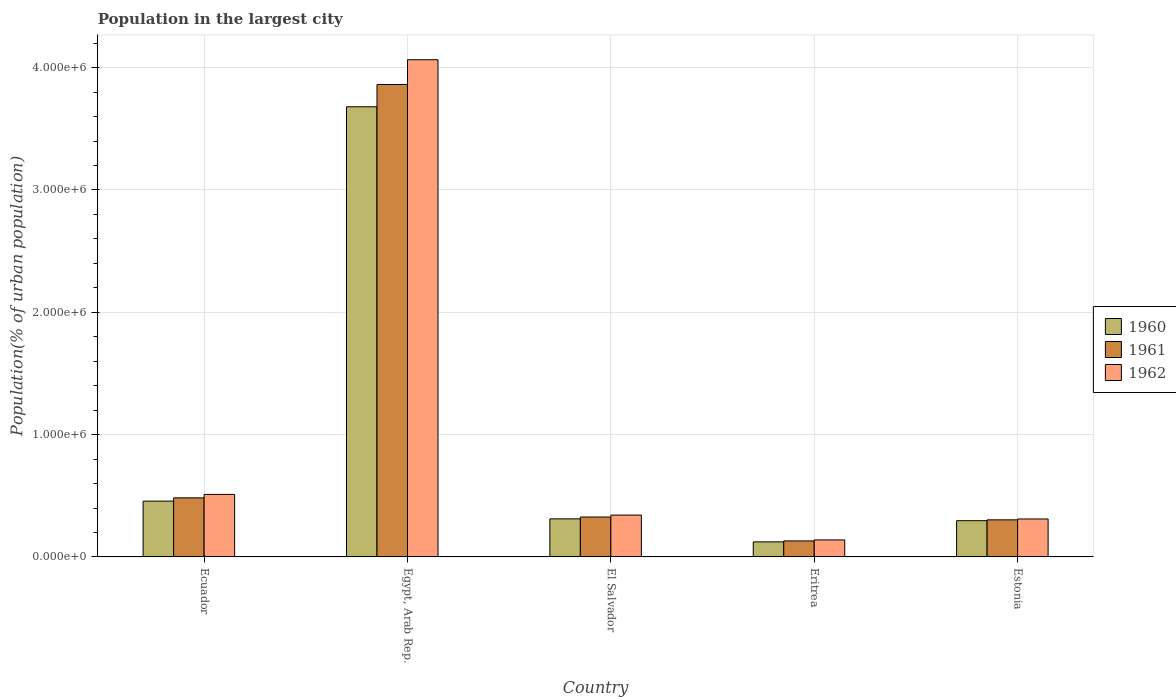Are the number of bars per tick equal to the number of legend labels?
Provide a succinct answer. Yes. Are the number of bars on each tick of the X-axis equal?
Provide a short and direct response. Yes. How many bars are there on the 1st tick from the right?
Ensure brevity in your answer.  3. What is the label of the 3rd group of bars from the left?
Make the answer very short. El Salvador. In how many cases, is the number of bars for a given country not equal to the number of legend labels?
Offer a very short reply. 0. What is the population in the largest city in 1960 in El Salvador?
Provide a succinct answer. 3.11e+05. Across all countries, what is the maximum population in the largest city in 1961?
Your answer should be very brief. 3.86e+06. Across all countries, what is the minimum population in the largest city in 1961?
Ensure brevity in your answer.  1.31e+05. In which country was the population in the largest city in 1960 maximum?
Keep it short and to the point. Egypt, Arab Rep. In which country was the population in the largest city in 1960 minimum?
Ensure brevity in your answer.  Eritrea. What is the total population in the largest city in 1960 in the graph?
Ensure brevity in your answer.  4.87e+06. What is the difference between the population in the largest city in 1962 in El Salvador and that in Estonia?
Offer a terse response. 3.18e+04. What is the difference between the population in the largest city in 1960 in Estonia and the population in the largest city in 1961 in Ecuador?
Make the answer very short. -1.87e+05. What is the average population in the largest city in 1960 per country?
Your answer should be compact. 9.73e+05. What is the difference between the population in the largest city of/in 1960 and population in the largest city of/in 1961 in Estonia?
Provide a succinct answer. -6898. In how many countries, is the population in the largest city in 1960 greater than 2200000 %?
Your answer should be very brief. 1. What is the ratio of the population in the largest city in 1961 in Ecuador to that in Eritrea?
Ensure brevity in your answer.  3.69. Is the population in the largest city in 1962 in Egypt, Arab Rep. less than that in El Salvador?
Give a very brief answer. No. What is the difference between the highest and the second highest population in the largest city in 1960?
Provide a succinct answer. 3.22e+06. What is the difference between the highest and the lowest population in the largest city in 1961?
Keep it short and to the point. 3.73e+06. In how many countries, is the population in the largest city in 1962 greater than the average population in the largest city in 1962 taken over all countries?
Your response must be concise. 1. What does the 3rd bar from the left in Egypt, Arab Rep. represents?
Your response must be concise. 1962. Is it the case that in every country, the sum of the population in the largest city in 1962 and population in the largest city in 1960 is greater than the population in the largest city in 1961?
Provide a short and direct response. Yes. How many bars are there?
Offer a very short reply. 15. Does the graph contain any zero values?
Your answer should be compact. No. Where does the legend appear in the graph?
Keep it short and to the point. Center right. How are the legend labels stacked?
Your answer should be very brief. Vertical. What is the title of the graph?
Provide a short and direct response. Population in the largest city. Does "2009" appear as one of the legend labels in the graph?
Ensure brevity in your answer.  No. What is the label or title of the X-axis?
Your answer should be very brief. Country. What is the label or title of the Y-axis?
Your answer should be compact. Population(% of urban population). What is the Population(% of urban population) of 1960 in Ecuador?
Provide a succinct answer. 4.56e+05. What is the Population(% of urban population) in 1961 in Ecuador?
Ensure brevity in your answer.  4.83e+05. What is the Population(% of urban population) in 1962 in Ecuador?
Your answer should be compact. 5.11e+05. What is the Population(% of urban population) of 1960 in Egypt, Arab Rep.?
Keep it short and to the point. 3.68e+06. What is the Population(% of urban population) of 1961 in Egypt, Arab Rep.?
Make the answer very short. 3.86e+06. What is the Population(% of urban population) of 1962 in Egypt, Arab Rep.?
Provide a succinct answer. 4.06e+06. What is the Population(% of urban population) of 1960 in El Salvador?
Provide a short and direct response. 3.11e+05. What is the Population(% of urban population) in 1961 in El Salvador?
Your response must be concise. 3.26e+05. What is the Population(% of urban population) of 1962 in El Salvador?
Provide a succinct answer. 3.42e+05. What is the Population(% of urban population) in 1960 in Eritrea?
Make the answer very short. 1.23e+05. What is the Population(% of urban population) of 1961 in Eritrea?
Keep it short and to the point. 1.31e+05. What is the Population(% of urban population) in 1962 in Eritrea?
Offer a very short reply. 1.39e+05. What is the Population(% of urban population) of 1960 in Estonia?
Offer a terse response. 2.96e+05. What is the Population(% of urban population) in 1961 in Estonia?
Provide a short and direct response. 3.03e+05. What is the Population(% of urban population) of 1962 in Estonia?
Make the answer very short. 3.10e+05. Across all countries, what is the maximum Population(% of urban population) in 1960?
Offer a terse response. 3.68e+06. Across all countries, what is the maximum Population(% of urban population) in 1961?
Give a very brief answer. 3.86e+06. Across all countries, what is the maximum Population(% of urban population) in 1962?
Keep it short and to the point. 4.06e+06. Across all countries, what is the minimum Population(% of urban population) in 1960?
Your answer should be compact. 1.23e+05. Across all countries, what is the minimum Population(% of urban population) of 1961?
Offer a very short reply. 1.31e+05. Across all countries, what is the minimum Population(% of urban population) of 1962?
Your answer should be very brief. 1.39e+05. What is the total Population(% of urban population) of 1960 in the graph?
Your response must be concise. 4.87e+06. What is the total Population(% of urban population) of 1961 in the graph?
Give a very brief answer. 5.11e+06. What is the total Population(% of urban population) of 1962 in the graph?
Your answer should be very brief. 5.37e+06. What is the difference between the Population(% of urban population) in 1960 in Ecuador and that in Egypt, Arab Rep.?
Your answer should be very brief. -3.22e+06. What is the difference between the Population(% of urban population) in 1961 in Ecuador and that in Egypt, Arab Rep.?
Provide a short and direct response. -3.38e+06. What is the difference between the Population(% of urban population) of 1962 in Ecuador and that in Egypt, Arab Rep.?
Ensure brevity in your answer.  -3.55e+06. What is the difference between the Population(% of urban population) in 1960 in Ecuador and that in El Salvador?
Offer a terse response. 1.45e+05. What is the difference between the Population(% of urban population) in 1961 in Ecuador and that in El Salvador?
Provide a short and direct response. 1.57e+05. What is the difference between the Population(% of urban population) of 1962 in Ecuador and that in El Salvador?
Keep it short and to the point. 1.69e+05. What is the difference between the Population(% of urban population) of 1960 in Ecuador and that in Eritrea?
Ensure brevity in your answer.  3.33e+05. What is the difference between the Population(% of urban population) in 1961 in Ecuador and that in Eritrea?
Ensure brevity in your answer.  3.52e+05. What is the difference between the Population(% of urban population) in 1962 in Ecuador and that in Eritrea?
Offer a terse response. 3.72e+05. What is the difference between the Population(% of urban population) of 1960 in Ecuador and that in Estonia?
Offer a terse response. 1.60e+05. What is the difference between the Population(% of urban population) in 1961 in Ecuador and that in Estonia?
Offer a terse response. 1.80e+05. What is the difference between the Population(% of urban population) of 1962 in Ecuador and that in Estonia?
Offer a very short reply. 2.01e+05. What is the difference between the Population(% of urban population) in 1960 in Egypt, Arab Rep. and that in El Salvador?
Ensure brevity in your answer.  3.37e+06. What is the difference between the Population(% of urban population) in 1961 in Egypt, Arab Rep. and that in El Salvador?
Provide a short and direct response. 3.54e+06. What is the difference between the Population(% of urban population) of 1962 in Egypt, Arab Rep. and that in El Salvador?
Give a very brief answer. 3.72e+06. What is the difference between the Population(% of urban population) in 1960 in Egypt, Arab Rep. and that in Eritrea?
Make the answer very short. 3.56e+06. What is the difference between the Population(% of urban population) of 1961 in Egypt, Arab Rep. and that in Eritrea?
Provide a short and direct response. 3.73e+06. What is the difference between the Population(% of urban population) in 1962 in Egypt, Arab Rep. and that in Eritrea?
Ensure brevity in your answer.  3.93e+06. What is the difference between the Population(% of urban population) in 1960 in Egypt, Arab Rep. and that in Estonia?
Your response must be concise. 3.38e+06. What is the difference between the Population(% of urban population) of 1961 in Egypt, Arab Rep. and that in Estonia?
Offer a terse response. 3.56e+06. What is the difference between the Population(% of urban population) of 1962 in Egypt, Arab Rep. and that in Estonia?
Offer a very short reply. 3.75e+06. What is the difference between the Population(% of urban population) of 1960 in El Salvador and that in Eritrea?
Offer a terse response. 1.88e+05. What is the difference between the Population(% of urban population) in 1961 in El Salvador and that in Eritrea?
Keep it short and to the point. 1.95e+05. What is the difference between the Population(% of urban population) of 1962 in El Salvador and that in Eritrea?
Provide a succinct answer. 2.03e+05. What is the difference between the Population(% of urban population) of 1960 in El Salvador and that in Estonia?
Make the answer very short. 1.49e+04. What is the difference between the Population(% of urban population) in 1961 in El Salvador and that in Estonia?
Offer a very short reply. 2.30e+04. What is the difference between the Population(% of urban population) in 1962 in El Salvador and that in Estonia?
Offer a terse response. 3.18e+04. What is the difference between the Population(% of urban population) in 1960 in Eritrea and that in Estonia?
Ensure brevity in your answer.  -1.73e+05. What is the difference between the Population(% of urban population) in 1961 in Eritrea and that in Estonia?
Your answer should be very brief. -1.72e+05. What is the difference between the Population(% of urban population) in 1962 in Eritrea and that in Estonia?
Give a very brief answer. -1.71e+05. What is the difference between the Population(% of urban population) in 1960 in Ecuador and the Population(% of urban population) in 1961 in Egypt, Arab Rep.?
Give a very brief answer. -3.41e+06. What is the difference between the Population(% of urban population) in 1960 in Ecuador and the Population(% of urban population) in 1962 in Egypt, Arab Rep.?
Your answer should be compact. -3.61e+06. What is the difference between the Population(% of urban population) in 1961 in Ecuador and the Population(% of urban population) in 1962 in Egypt, Arab Rep.?
Your response must be concise. -3.58e+06. What is the difference between the Population(% of urban population) in 1960 in Ecuador and the Population(% of urban population) in 1961 in El Salvador?
Offer a very short reply. 1.30e+05. What is the difference between the Population(% of urban population) in 1960 in Ecuador and the Population(% of urban population) in 1962 in El Salvador?
Your answer should be compact. 1.14e+05. What is the difference between the Population(% of urban population) of 1961 in Ecuador and the Population(% of urban population) of 1962 in El Salvador?
Offer a terse response. 1.41e+05. What is the difference between the Population(% of urban population) of 1960 in Ecuador and the Population(% of urban population) of 1961 in Eritrea?
Provide a succinct answer. 3.25e+05. What is the difference between the Population(% of urban population) in 1960 in Ecuador and the Population(% of urban population) in 1962 in Eritrea?
Keep it short and to the point. 3.17e+05. What is the difference between the Population(% of urban population) of 1961 in Ecuador and the Population(% of urban population) of 1962 in Eritrea?
Provide a succinct answer. 3.44e+05. What is the difference between the Population(% of urban population) in 1960 in Ecuador and the Population(% of urban population) in 1961 in Estonia?
Offer a terse response. 1.53e+05. What is the difference between the Population(% of urban population) of 1960 in Ecuador and the Population(% of urban population) of 1962 in Estonia?
Make the answer very short. 1.46e+05. What is the difference between the Population(% of urban population) of 1961 in Ecuador and the Population(% of urban population) of 1962 in Estonia?
Ensure brevity in your answer.  1.73e+05. What is the difference between the Population(% of urban population) in 1960 in Egypt, Arab Rep. and the Population(% of urban population) in 1961 in El Salvador?
Give a very brief answer. 3.35e+06. What is the difference between the Population(% of urban population) of 1960 in Egypt, Arab Rep. and the Population(% of urban population) of 1962 in El Salvador?
Your response must be concise. 3.34e+06. What is the difference between the Population(% of urban population) in 1961 in Egypt, Arab Rep. and the Population(% of urban population) in 1962 in El Salvador?
Your answer should be compact. 3.52e+06. What is the difference between the Population(% of urban population) of 1960 in Egypt, Arab Rep. and the Population(% of urban population) of 1961 in Eritrea?
Ensure brevity in your answer.  3.55e+06. What is the difference between the Population(% of urban population) of 1960 in Egypt, Arab Rep. and the Population(% of urban population) of 1962 in Eritrea?
Give a very brief answer. 3.54e+06. What is the difference between the Population(% of urban population) in 1961 in Egypt, Arab Rep. and the Population(% of urban population) in 1962 in Eritrea?
Your answer should be very brief. 3.72e+06. What is the difference between the Population(% of urban population) of 1960 in Egypt, Arab Rep. and the Population(% of urban population) of 1961 in Estonia?
Provide a succinct answer. 3.38e+06. What is the difference between the Population(% of urban population) in 1960 in Egypt, Arab Rep. and the Population(% of urban population) in 1962 in Estonia?
Make the answer very short. 3.37e+06. What is the difference between the Population(% of urban population) of 1961 in Egypt, Arab Rep. and the Population(% of urban population) of 1962 in Estonia?
Your response must be concise. 3.55e+06. What is the difference between the Population(% of urban population) in 1960 in El Salvador and the Population(% of urban population) in 1961 in Eritrea?
Your answer should be compact. 1.80e+05. What is the difference between the Population(% of urban population) of 1960 in El Salvador and the Population(% of urban population) of 1962 in Eritrea?
Your response must be concise. 1.72e+05. What is the difference between the Population(% of urban population) of 1961 in El Salvador and the Population(% of urban population) of 1962 in Eritrea?
Provide a succinct answer. 1.87e+05. What is the difference between the Population(% of urban population) in 1960 in El Salvador and the Population(% of urban population) in 1961 in Estonia?
Ensure brevity in your answer.  8011. What is the difference between the Population(% of urban population) in 1960 in El Salvador and the Population(% of urban population) in 1962 in Estonia?
Provide a succinct answer. 942. What is the difference between the Population(% of urban population) of 1961 in El Salvador and the Population(% of urban population) of 1962 in Estonia?
Give a very brief answer. 1.60e+04. What is the difference between the Population(% of urban population) of 1960 in Eritrea and the Population(% of urban population) of 1961 in Estonia?
Provide a short and direct response. -1.80e+05. What is the difference between the Population(% of urban population) in 1960 in Eritrea and the Population(% of urban population) in 1962 in Estonia?
Make the answer very short. -1.87e+05. What is the difference between the Population(% of urban population) in 1961 in Eritrea and the Population(% of urban population) in 1962 in Estonia?
Provide a short and direct response. -1.79e+05. What is the average Population(% of urban population) in 1960 per country?
Your answer should be compact. 9.73e+05. What is the average Population(% of urban population) in 1961 per country?
Offer a terse response. 1.02e+06. What is the average Population(% of urban population) of 1962 per country?
Provide a short and direct response. 1.07e+06. What is the difference between the Population(% of urban population) in 1960 and Population(% of urban population) in 1961 in Ecuador?
Provide a short and direct response. -2.66e+04. What is the difference between the Population(% of urban population) of 1960 and Population(% of urban population) of 1962 in Ecuador?
Your answer should be compact. -5.49e+04. What is the difference between the Population(% of urban population) of 1961 and Population(% of urban population) of 1962 in Ecuador?
Your answer should be compact. -2.82e+04. What is the difference between the Population(% of urban population) of 1960 and Population(% of urban population) of 1961 in Egypt, Arab Rep.?
Offer a terse response. -1.82e+05. What is the difference between the Population(% of urban population) in 1960 and Population(% of urban population) in 1962 in Egypt, Arab Rep.?
Your response must be concise. -3.85e+05. What is the difference between the Population(% of urban population) in 1961 and Population(% of urban population) in 1962 in Egypt, Arab Rep.?
Provide a succinct answer. -2.02e+05. What is the difference between the Population(% of urban population) of 1960 and Population(% of urban population) of 1961 in El Salvador?
Your answer should be compact. -1.50e+04. What is the difference between the Population(% of urban population) in 1960 and Population(% of urban population) in 1962 in El Salvador?
Give a very brief answer. -3.08e+04. What is the difference between the Population(% of urban population) of 1961 and Population(% of urban population) of 1962 in El Salvador?
Make the answer very short. -1.58e+04. What is the difference between the Population(% of urban population) of 1960 and Population(% of urban population) of 1961 in Eritrea?
Your answer should be compact. -7673. What is the difference between the Population(% of urban population) in 1960 and Population(% of urban population) in 1962 in Eritrea?
Your response must be concise. -1.58e+04. What is the difference between the Population(% of urban population) of 1961 and Population(% of urban population) of 1962 in Eritrea?
Offer a terse response. -8161. What is the difference between the Population(% of urban population) in 1960 and Population(% of urban population) in 1961 in Estonia?
Your answer should be compact. -6898. What is the difference between the Population(% of urban population) in 1960 and Population(% of urban population) in 1962 in Estonia?
Ensure brevity in your answer.  -1.40e+04. What is the difference between the Population(% of urban population) in 1961 and Population(% of urban population) in 1962 in Estonia?
Make the answer very short. -7069. What is the ratio of the Population(% of urban population) in 1960 in Ecuador to that in Egypt, Arab Rep.?
Keep it short and to the point. 0.12. What is the ratio of the Population(% of urban population) of 1961 in Ecuador to that in Egypt, Arab Rep.?
Your response must be concise. 0.12. What is the ratio of the Population(% of urban population) in 1962 in Ecuador to that in Egypt, Arab Rep.?
Give a very brief answer. 0.13. What is the ratio of the Population(% of urban population) in 1960 in Ecuador to that in El Salvador?
Your answer should be very brief. 1.47. What is the ratio of the Population(% of urban population) of 1961 in Ecuador to that in El Salvador?
Offer a very short reply. 1.48. What is the ratio of the Population(% of urban population) of 1962 in Ecuador to that in El Salvador?
Your answer should be compact. 1.49. What is the ratio of the Population(% of urban population) of 1960 in Ecuador to that in Eritrea?
Offer a terse response. 3.7. What is the ratio of the Population(% of urban population) of 1961 in Ecuador to that in Eritrea?
Make the answer very short. 3.69. What is the ratio of the Population(% of urban population) of 1962 in Ecuador to that in Eritrea?
Your answer should be very brief. 3.68. What is the ratio of the Population(% of urban population) in 1960 in Ecuador to that in Estonia?
Give a very brief answer. 1.54. What is the ratio of the Population(% of urban population) in 1961 in Ecuador to that in Estonia?
Offer a terse response. 1.59. What is the ratio of the Population(% of urban population) in 1962 in Ecuador to that in Estonia?
Provide a short and direct response. 1.65. What is the ratio of the Population(% of urban population) of 1960 in Egypt, Arab Rep. to that in El Salvador?
Offer a very short reply. 11.83. What is the ratio of the Population(% of urban population) in 1961 in Egypt, Arab Rep. to that in El Salvador?
Your answer should be very brief. 11.84. What is the ratio of the Population(% of urban population) of 1962 in Egypt, Arab Rep. to that in El Salvador?
Your answer should be compact. 11.88. What is the ratio of the Population(% of urban population) of 1960 in Egypt, Arab Rep. to that in Eritrea?
Provide a short and direct response. 29.88. What is the ratio of the Population(% of urban population) of 1961 in Egypt, Arab Rep. to that in Eritrea?
Provide a short and direct response. 29.52. What is the ratio of the Population(% of urban population) of 1962 in Egypt, Arab Rep. to that in Eritrea?
Provide a short and direct response. 29.24. What is the ratio of the Population(% of urban population) of 1960 in Egypt, Arab Rep. to that in Estonia?
Your answer should be very brief. 12.42. What is the ratio of the Population(% of urban population) of 1961 in Egypt, Arab Rep. to that in Estonia?
Offer a terse response. 12.74. What is the ratio of the Population(% of urban population) of 1962 in Egypt, Arab Rep. to that in Estonia?
Keep it short and to the point. 13.1. What is the ratio of the Population(% of urban population) of 1960 in El Salvador to that in Eritrea?
Ensure brevity in your answer.  2.53. What is the ratio of the Population(% of urban population) in 1961 in El Salvador to that in Eritrea?
Provide a succinct answer. 2.49. What is the ratio of the Population(% of urban population) of 1962 in El Salvador to that in Eritrea?
Keep it short and to the point. 2.46. What is the ratio of the Population(% of urban population) of 1960 in El Salvador to that in Estonia?
Ensure brevity in your answer.  1.05. What is the ratio of the Population(% of urban population) in 1961 in El Salvador to that in Estonia?
Your answer should be compact. 1.08. What is the ratio of the Population(% of urban population) in 1962 in El Salvador to that in Estonia?
Give a very brief answer. 1.1. What is the ratio of the Population(% of urban population) of 1960 in Eritrea to that in Estonia?
Ensure brevity in your answer.  0.42. What is the ratio of the Population(% of urban population) in 1961 in Eritrea to that in Estonia?
Ensure brevity in your answer.  0.43. What is the ratio of the Population(% of urban population) in 1962 in Eritrea to that in Estonia?
Make the answer very short. 0.45. What is the difference between the highest and the second highest Population(% of urban population) of 1960?
Your answer should be compact. 3.22e+06. What is the difference between the highest and the second highest Population(% of urban population) of 1961?
Provide a short and direct response. 3.38e+06. What is the difference between the highest and the second highest Population(% of urban population) in 1962?
Provide a short and direct response. 3.55e+06. What is the difference between the highest and the lowest Population(% of urban population) of 1960?
Ensure brevity in your answer.  3.56e+06. What is the difference between the highest and the lowest Population(% of urban population) in 1961?
Your answer should be very brief. 3.73e+06. What is the difference between the highest and the lowest Population(% of urban population) in 1962?
Provide a succinct answer. 3.93e+06. 